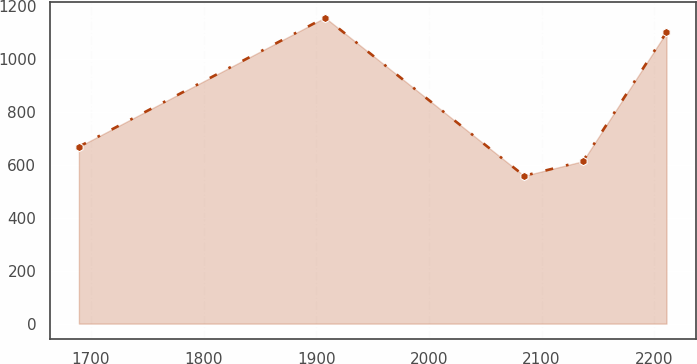Convert chart to OTSL. <chart><loc_0><loc_0><loc_500><loc_500><line_chart><ecel><fcel>Unnamed: 1<nl><fcel>1689.31<fcel>667.61<nl><fcel>1907.83<fcel>1154.52<nl><fcel>2084.54<fcel>557.79<nl><fcel>2136.7<fcel>612.7<nl><fcel>2210.96<fcel>1099.61<nl></chart> 